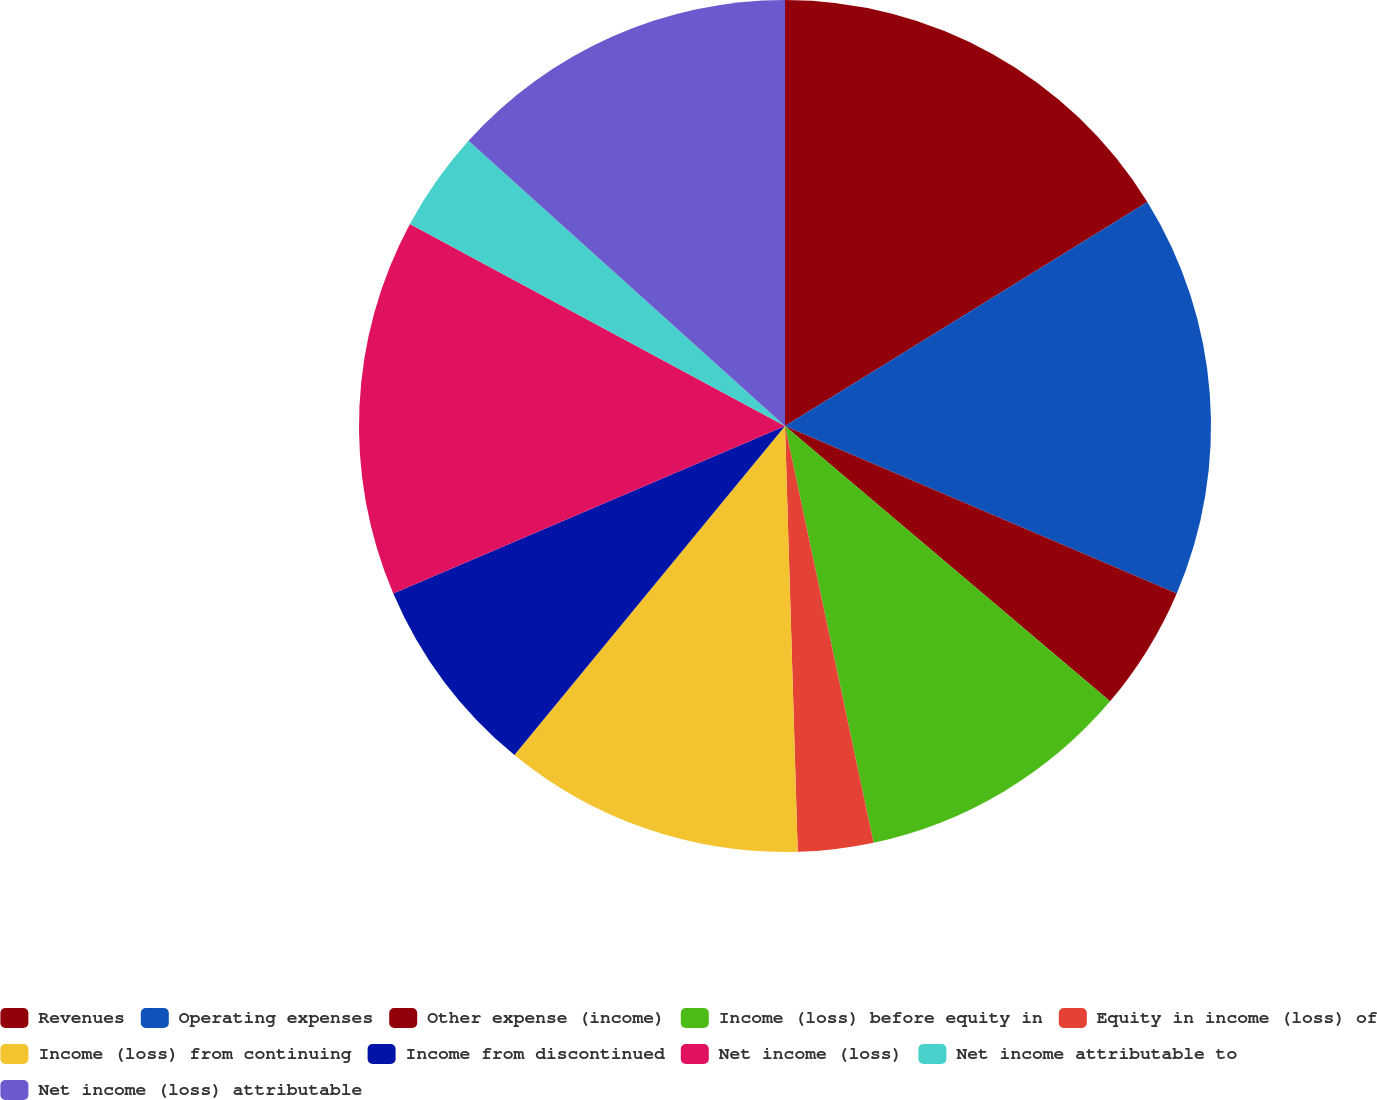<chart> <loc_0><loc_0><loc_500><loc_500><pie_chart><fcel>Revenues<fcel>Operating expenses<fcel>Other expense (income)<fcel>Income (loss) before equity in<fcel>Equity in income (loss) of<fcel>Income (loss) from continuing<fcel>Income from discontinued<fcel>Net income (loss)<fcel>Net income attributable to<fcel>Net income (loss) attributable<nl><fcel>16.19%<fcel>15.24%<fcel>4.76%<fcel>10.48%<fcel>2.86%<fcel>11.43%<fcel>7.62%<fcel>14.29%<fcel>3.81%<fcel>13.33%<nl></chart> 